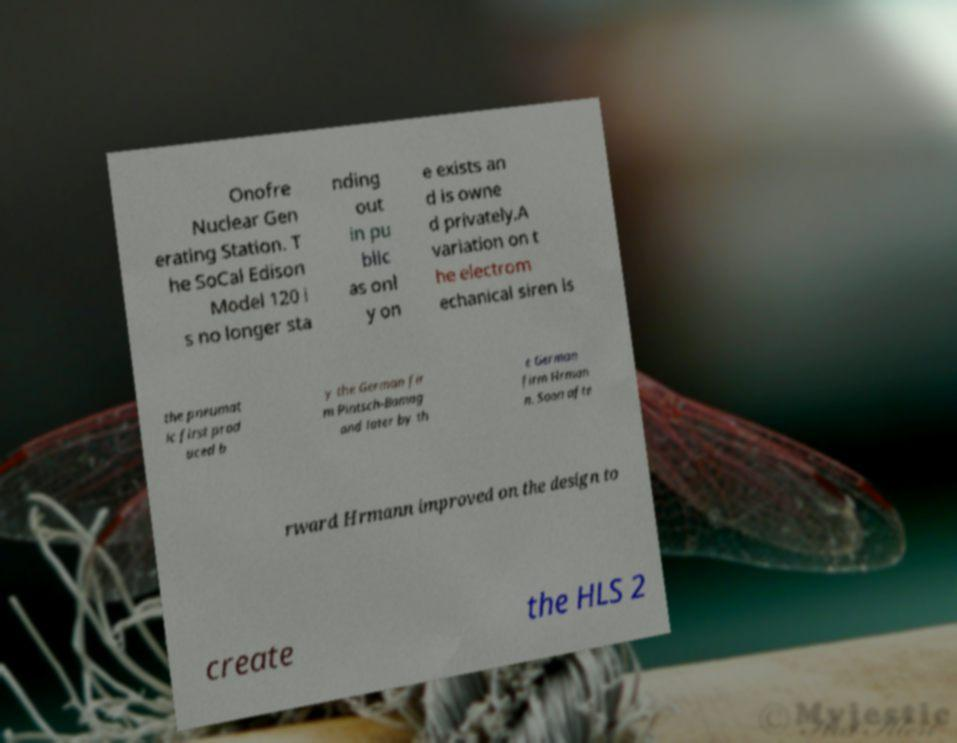Can you accurately transcribe the text from the provided image for me? Onofre Nuclear Gen erating Station. T he SoCal Edison Model 120 i s no longer sta nding out in pu blic as onl y on e exists an d is owne d privately.A variation on t he electrom echanical siren is the pneumat ic first prod uced b y the German fir m Pintsch-Bamag and later by th e German firm Hrman n. Soon afte rward Hrmann improved on the design to create the HLS 2 